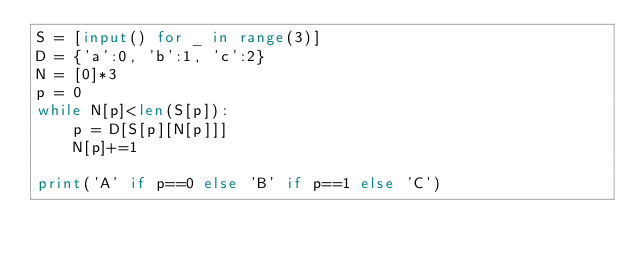<code> <loc_0><loc_0><loc_500><loc_500><_Python_>S = [input() for _ in range(3)]
D = {'a':0, 'b':1, 'c':2}
N = [0]*3
p = 0
while N[p]<len(S[p]):
    p = D[S[p][N[p]]]
    N[p]+=1

print('A' if p==0 else 'B' if p==1 else 'C')</code> 